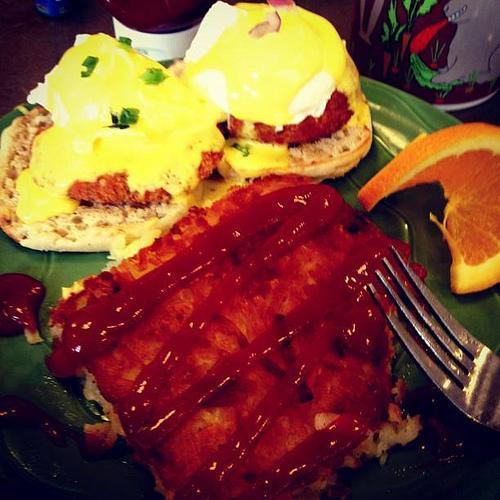How many english muffins are there?
Give a very brief answer. 2. 